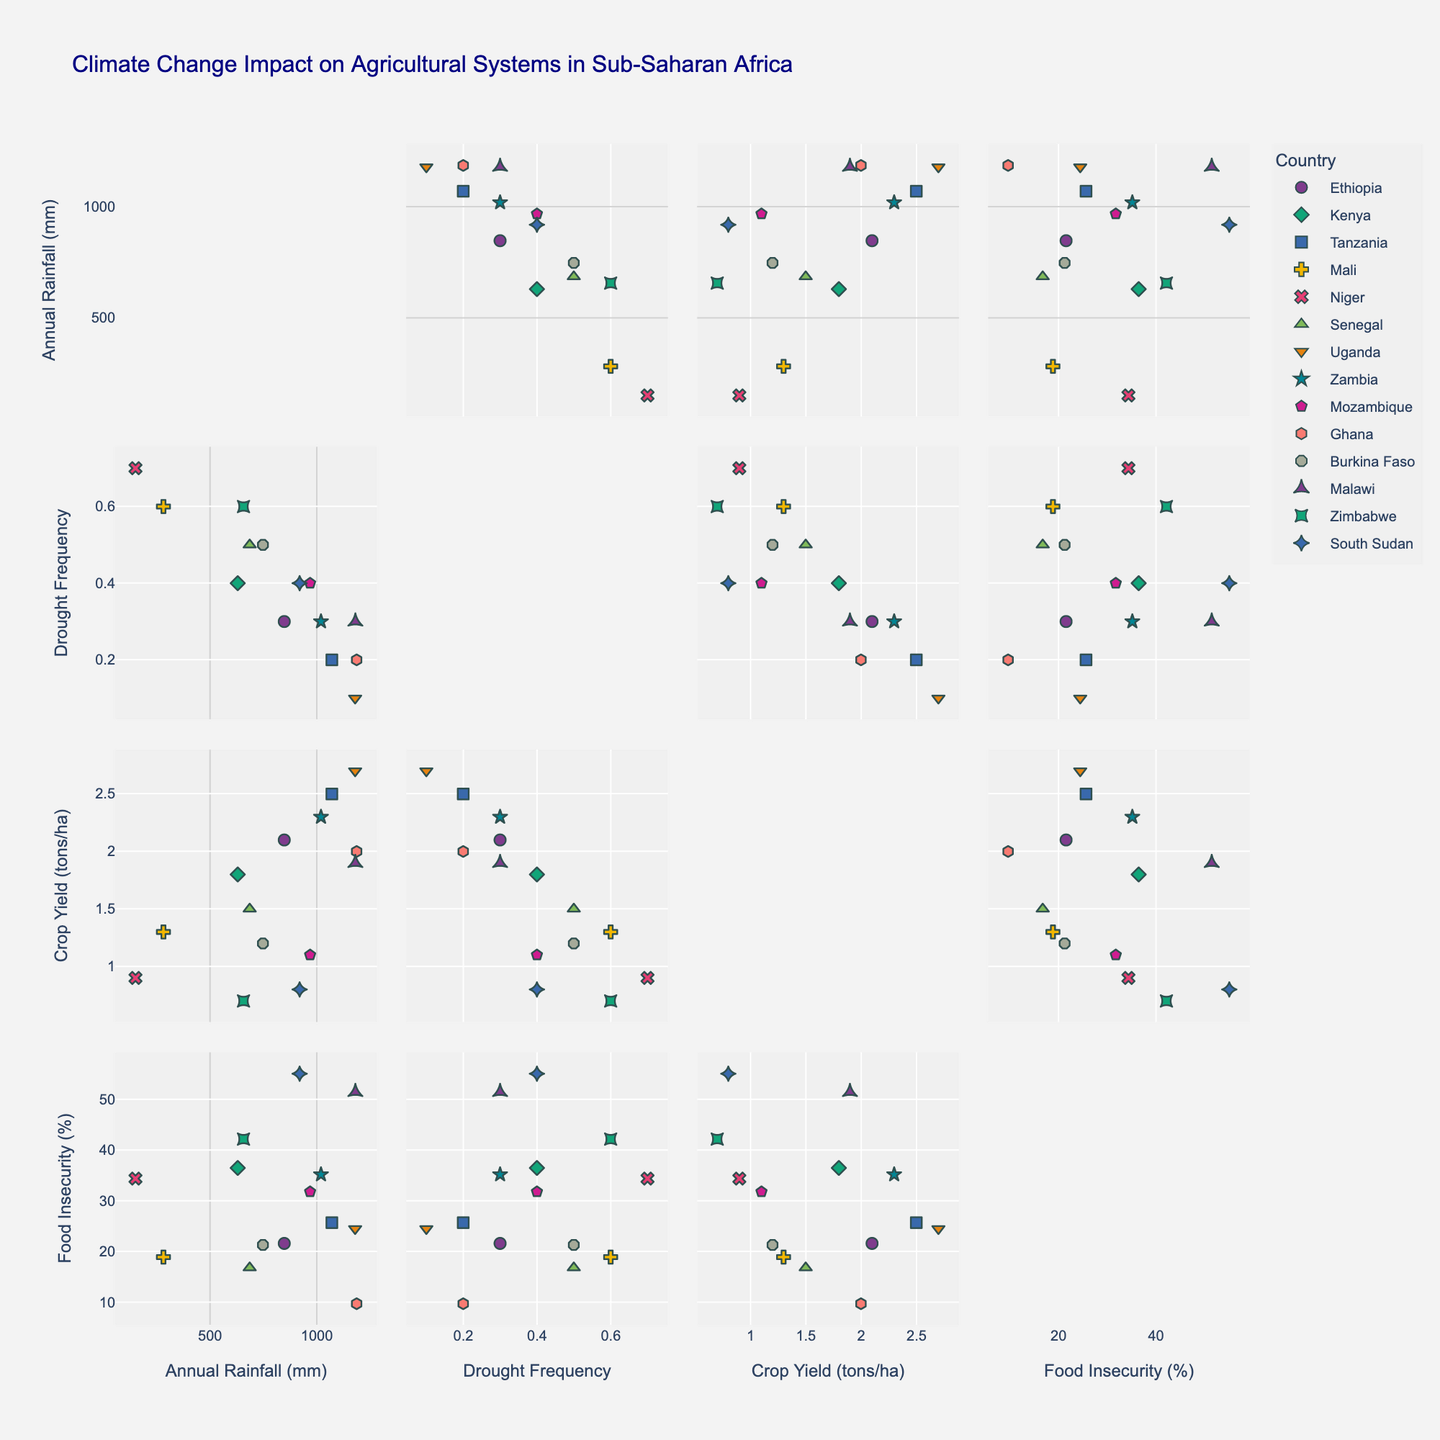what is the title of the figure? The title of a figure is typically located at the top of the plot and describes the main point or the content of the figure. In this case, the title of the figure is "Climate Change Impact on Agricultural Systems in Sub-Saharan Africa."
Answer: Climate Change Impact on Agricultural Systems in Sub-Saharan Africa How many variables are plotted in the scatterplot matrix? A scatterplot matrix visually displays multiple variables by showing scatter plots between each pair of variables. In this figure, the matrix includes 'Annual Rainfall (mm)', 'Drought Frequency', 'Crop Yield (tons/ha)', and 'Food Insecurity (%)' as the dimensions, giving a total of 4 plotted variables.
Answer: 4 Which country has the lowest crop yield? To determine the country with the lowest crop yield, we need to look at the scatterplots involving 'Crop Yield (tons/ha)' and identify which country is represented by the data point with the lowest value on that axis. From the data, Zimbabwe has a crop yield of 0.7 tons/hectare, the lowest in the dataset.
Answer: Zimbabwe Which two countries have the highest food insecurity prevalence? We examine the scatterplot involving 'Food Insecurity (%)' and look for the highest values along that axis, then identify which countries correspond to those data points. Malawi has a food insecurity prevalence of 51.5% and South Sudan has 55.1%, the two highest in the dataset.
Answer: Malawi, South Sudan What is the relationship between annual rainfall and drought frequency? To understand the relationship, we look at the scatterplot that has 'Annual Rainfall (mm)' on one axis and 'Drought Frequency' on the other. Generally, if there is a trend where higher rainfall correlates with lower drought frequency, it would indicate an inverse relationship. This correlation can be observed by the spread of data points; countries with lower rainfall tend to have higher drought frequencies.
Answer: Inverse relationship Which country has the highest annual rainfall, and what is its crop yield? To answer this, find the country with the highest point on the 'Annual Rainfall (mm)' axis and then check the corresponding value for 'Crop Yield (tons/ha)'. Ghana has the highest annual rainfall at 1187 mm, and its crop yield is 2.0 tons/hectare.
Answer: Ghana, 2.0 tons/hectare Are there more countries with above-average drought frequency or below-average crop yield? Calculate the averages for 'Drought Frequency' and 'Crop Yield (tons/ha)', then count how many countries are above or below these averages. Summing the drought frequencies and dividing by the number of countries gives an average drought frequency of approximately 0.38. Calculating similarly, the average crop yield is about 1.7 tons/hectare. More countries (7) have above-average drought frequency compared to those with below-average crop yield (5).
Answer: More with above-average drought frequency Which variable seems to have the strongest correlation with food insecurity prevalence? To determine this, we need to compare the scatterplots of 'Food Insecurity (%)' with each of the other three variables. The strength of the correlation can be visually assessed based on how tightly the data points align. 'Food Insecurity (%)' appears to have the strongest correlation with 'Drought Frequency', as points show a more defined trend compared to 'Annual Rainfall (mm)' or 'Crop Yield (tons/ha)'.
Answer: Drought Frequency Which country shows the largest discrepancy between annual rainfall and food insecurity prevalence? To find the largest discrepancy, look at countries with high rainfall but equally high food insecurity or low rainfall but low food insecurity. Uganda, despite an annual rainfall of 1180 mm (one of the highest), shows a relatively high food insecurity prevalence of 24.5%. This contrast indicates a significant discrepancy.
Answer: Uganda 